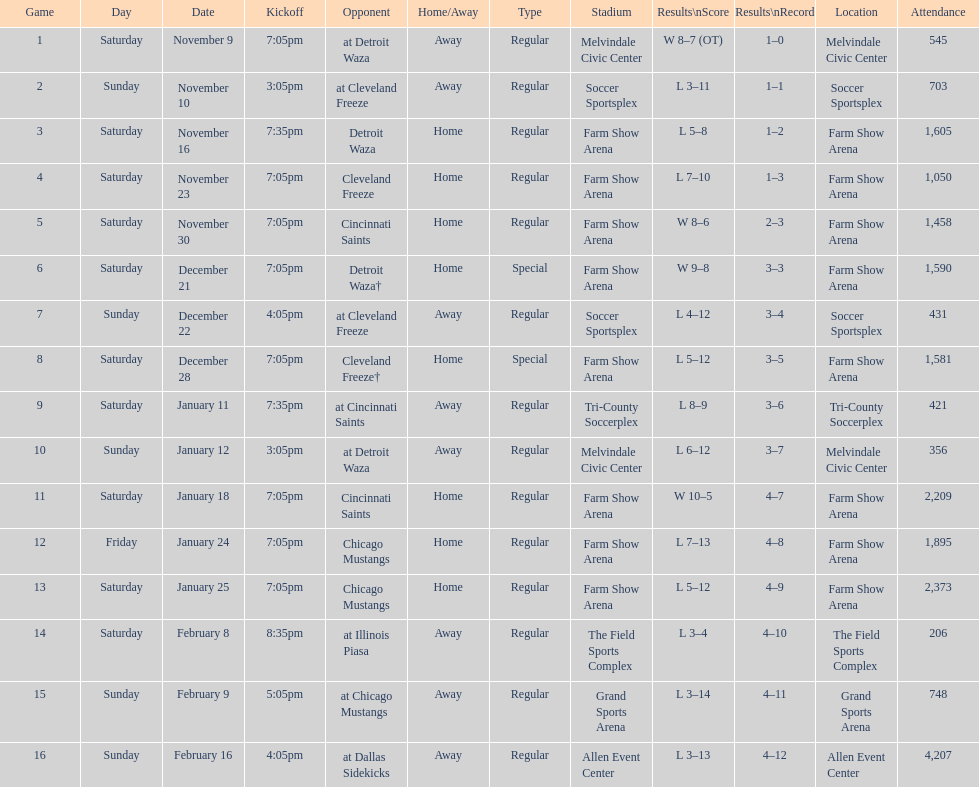How many games did the harrisburg heat lose to the cleveland freeze in total. 4. 